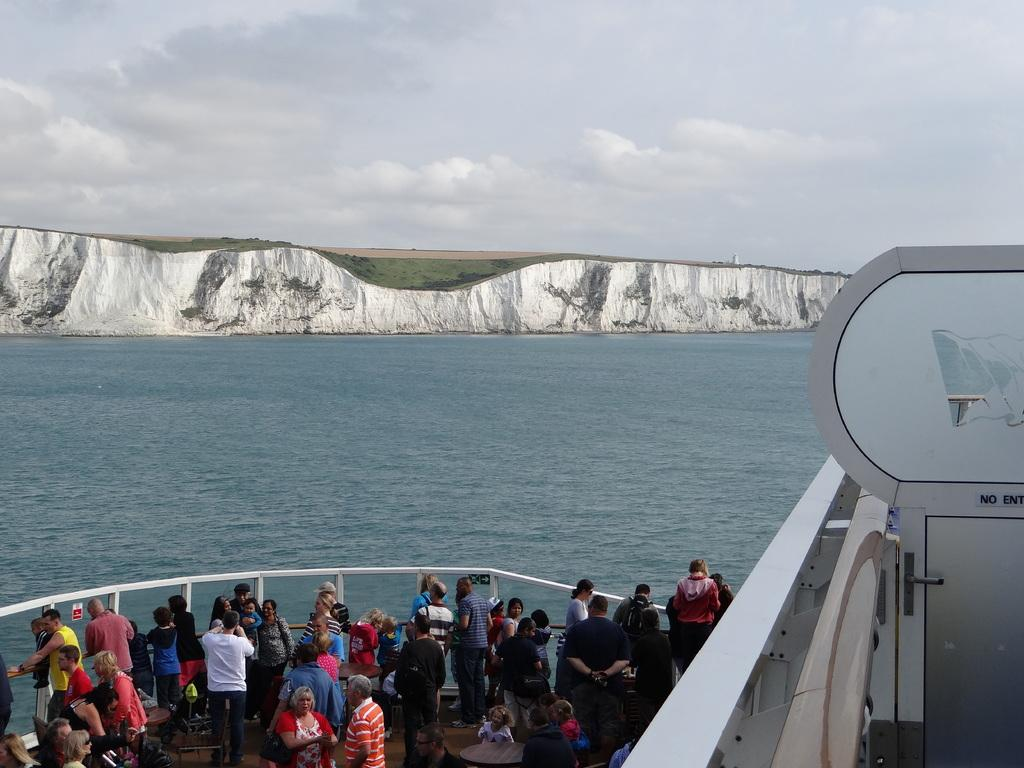What are the persons in the image doing? The persons in the image are standing in a boat. Where is the boat located? The boat is on the water and in the left corner of the image. What can be seen in the background of the image? There is a mountain in front of the persons in the boat. How many brushes are being used by the persons in the boat? There are no brushes visible in the image; the persons are standing in a boat on the water. Are there any cubs visible in the image? There are no cubs present in the image. 